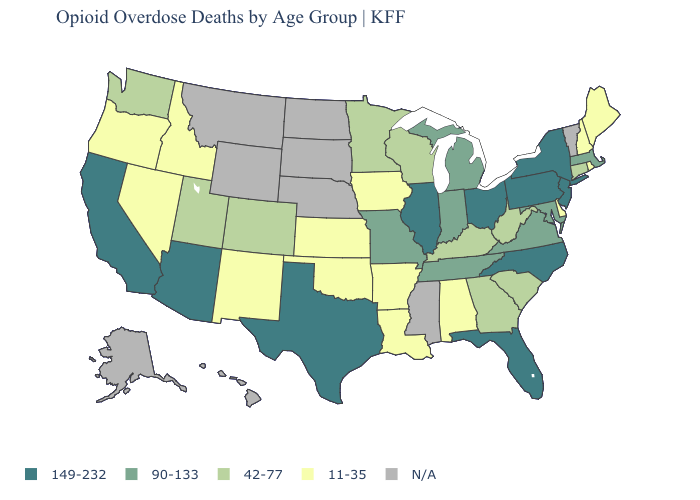What is the value of Alabama?
Answer briefly. 11-35. Does the map have missing data?
Short answer required. Yes. Which states have the lowest value in the West?
Answer briefly. Idaho, Nevada, New Mexico, Oregon. What is the value of Mississippi?
Short answer required. N/A. What is the highest value in states that border South Carolina?
Write a very short answer. 149-232. Name the states that have a value in the range 90-133?
Quick response, please. Indiana, Maryland, Massachusetts, Michigan, Missouri, Tennessee, Virginia. Among the states that border Missouri , which have the lowest value?
Write a very short answer. Arkansas, Iowa, Kansas, Oklahoma. What is the lowest value in states that border New Hampshire?
Give a very brief answer. 11-35. Name the states that have a value in the range 42-77?
Answer briefly. Colorado, Connecticut, Georgia, Kentucky, Minnesota, South Carolina, Utah, Washington, West Virginia, Wisconsin. Does Minnesota have the highest value in the USA?
Answer briefly. No. What is the value of Wisconsin?
Answer briefly. 42-77. What is the lowest value in the Northeast?
Give a very brief answer. 11-35. Which states have the lowest value in the USA?
Give a very brief answer. Alabama, Arkansas, Delaware, Idaho, Iowa, Kansas, Louisiana, Maine, Nevada, New Hampshire, New Mexico, Oklahoma, Oregon, Rhode Island. Name the states that have a value in the range 11-35?
Give a very brief answer. Alabama, Arkansas, Delaware, Idaho, Iowa, Kansas, Louisiana, Maine, Nevada, New Hampshire, New Mexico, Oklahoma, Oregon, Rhode Island. What is the value of Massachusetts?
Be succinct. 90-133. 